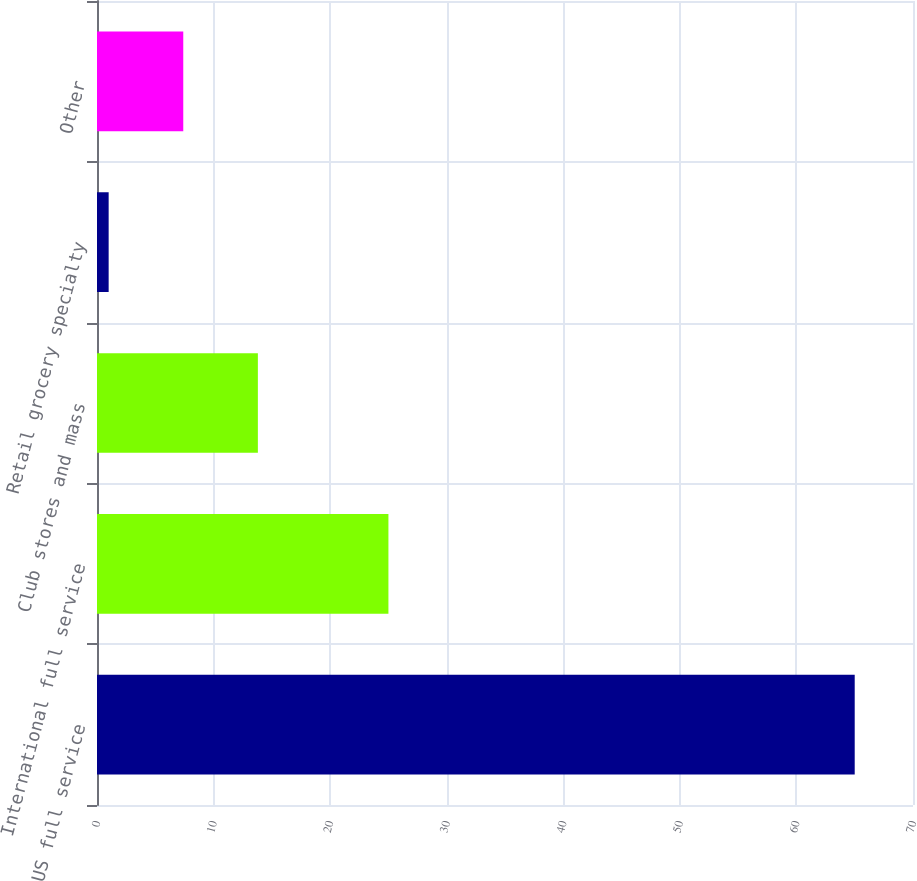Convert chart. <chart><loc_0><loc_0><loc_500><loc_500><bar_chart><fcel>US full service<fcel>International full service<fcel>Club stores and mass<fcel>Retail grocery specialty<fcel>Other<nl><fcel>65<fcel>25<fcel>13.8<fcel>1<fcel>7.4<nl></chart> 